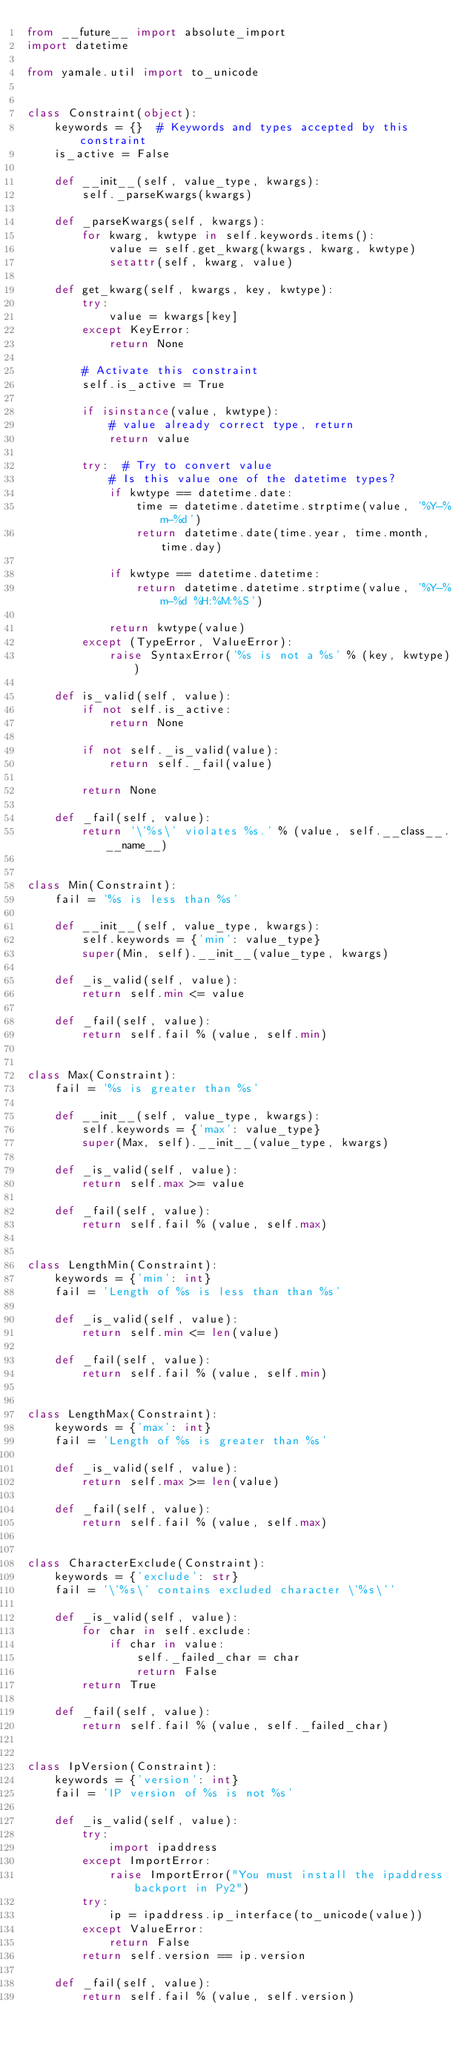<code> <loc_0><loc_0><loc_500><loc_500><_Python_>from __future__ import absolute_import
import datetime

from yamale.util import to_unicode


class Constraint(object):
    keywords = {}  # Keywords and types accepted by this constraint
    is_active = False

    def __init__(self, value_type, kwargs):
        self._parseKwargs(kwargs)

    def _parseKwargs(self, kwargs):
        for kwarg, kwtype in self.keywords.items():
            value = self.get_kwarg(kwargs, kwarg, kwtype)
            setattr(self, kwarg, value)

    def get_kwarg(self, kwargs, key, kwtype):
        try:
            value = kwargs[key]
        except KeyError:
            return None

        # Activate this constraint
        self.is_active = True

        if isinstance(value, kwtype):
            # value already correct type, return
            return value

        try:  # Try to convert value
            # Is this value one of the datetime types?
            if kwtype == datetime.date:
                time = datetime.datetime.strptime(value, '%Y-%m-%d')
                return datetime.date(time.year, time.month, time.day)

            if kwtype == datetime.datetime:
                return datetime.datetime.strptime(value, '%Y-%m-%d %H:%M:%S')

            return kwtype(value)
        except (TypeError, ValueError):
            raise SyntaxError('%s is not a %s' % (key, kwtype))

    def is_valid(self, value):
        if not self.is_active:
            return None

        if not self._is_valid(value):
            return self._fail(value)

        return None

    def _fail(self, value):
        return '\'%s\' violates %s.' % (value, self.__class__.__name__)


class Min(Constraint):
    fail = '%s is less than %s'

    def __init__(self, value_type, kwargs):
        self.keywords = {'min': value_type}
        super(Min, self).__init__(value_type, kwargs)

    def _is_valid(self, value):
        return self.min <= value

    def _fail(self, value):
        return self.fail % (value, self.min)


class Max(Constraint):
    fail = '%s is greater than %s'

    def __init__(self, value_type, kwargs):
        self.keywords = {'max': value_type}
        super(Max, self).__init__(value_type, kwargs)

    def _is_valid(self, value):
        return self.max >= value

    def _fail(self, value):
        return self.fail % (value, self.max)


class LengthMin(Constraint):
    keywords = {'min': int}
    fail = 'Length of %s is less than than %s'

    def _is_valid(self, value):
        return self.min <= len(value)

    def _fail(self, value):
        return self.fail % (value, self.min)


class LengthMax(Constraint):
    keywords = {'max': int}
    fail = 'Length of %s is greater than %s'

    def _is_valid(self, value):
        return self.max >= len(value)

    def _fail(self, value):
        return self.fail % (value, self.max)


class CharacterExclude(Constraint):
    keywords = {'exclude': str}
    fail = '\'%s\' contains excluded character \'%s\''

    def _is_valid(self, value):
        for char in self.exclude:
            if char in value:
                self._failed_char = char
                return False
        return True

    def _fail(self, value):
        return self.fail % (value, self._failed_char)


class IpVersion(Constraint):
    keywords = {'version': int}
    fail = 'IP version of %s is not %s'

    def _is_valid(self, value):
        try:
            import ipaddress
        except ImportError:
            raise ImportError("You must install the ipaddress backport in Py2")
        try:
            ip = ipaddress.ip_interface(to_unicode(value))
        except ValueError:
            return False
        return self.version == ip.version

    def _fail(self, value):
        return self.fail % (value, self.version)
</code> 